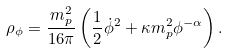<formula> <loc_0><loc_0><loc_500><loc_500>\rho _ { \phi } = \frac { m _ { p } ^ { 2 } } { 1 6 \pi } \left ( { \frac { 1 } { 2 } } \dot { \phi } ^ { 2 } + \kappa m _ { p } ^ { 2 } \phi ^ { - \alpha } \right ) .</formula> 